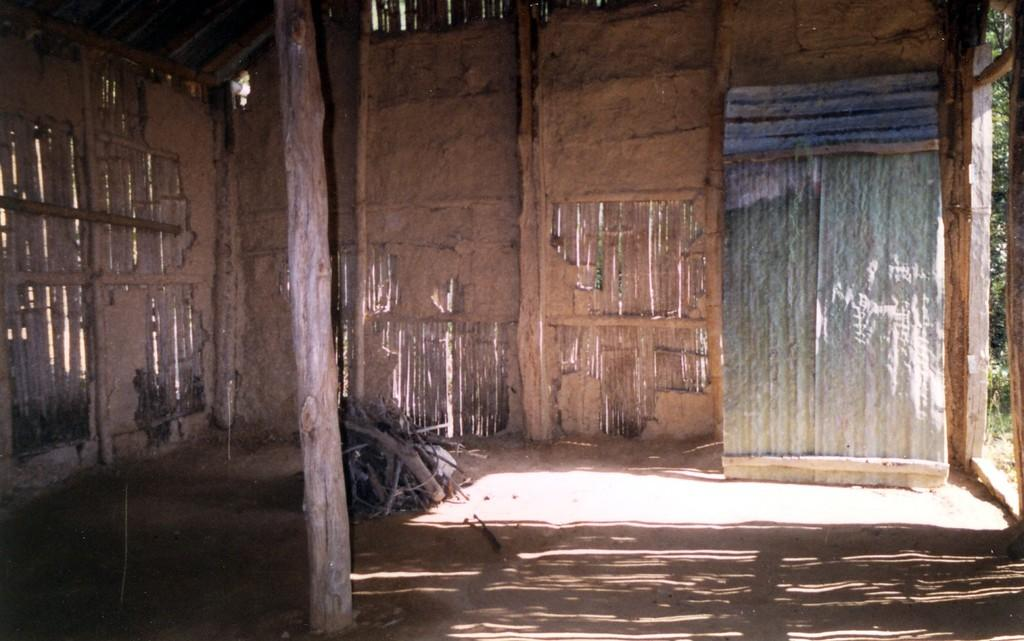What type of house is depicted in the image? There is a house made of sticks in the image. What material is used to construct the house? The house is made of sticks. Are there any other wooden objects in the image? Yes, there is a wooden stick and wooden twigs in the image. What can be seen on the right side of the image? There is a tree on the right side of the image. What type of blade can be seen in the image? There is no blade present in the image. Is there an owl perched on the tree in the image? There is no owl present in the image; only a tree is visible on the right side. 